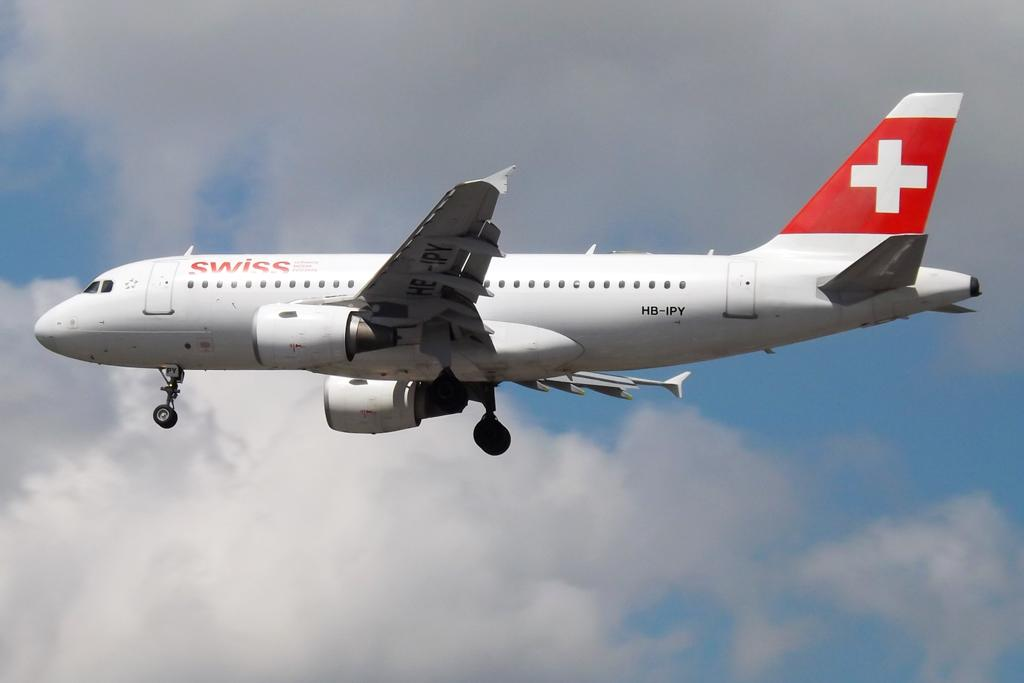<image>
Share a concise interpretation of the image provided. A SwissAir Airplane flying in a daytime sky. 